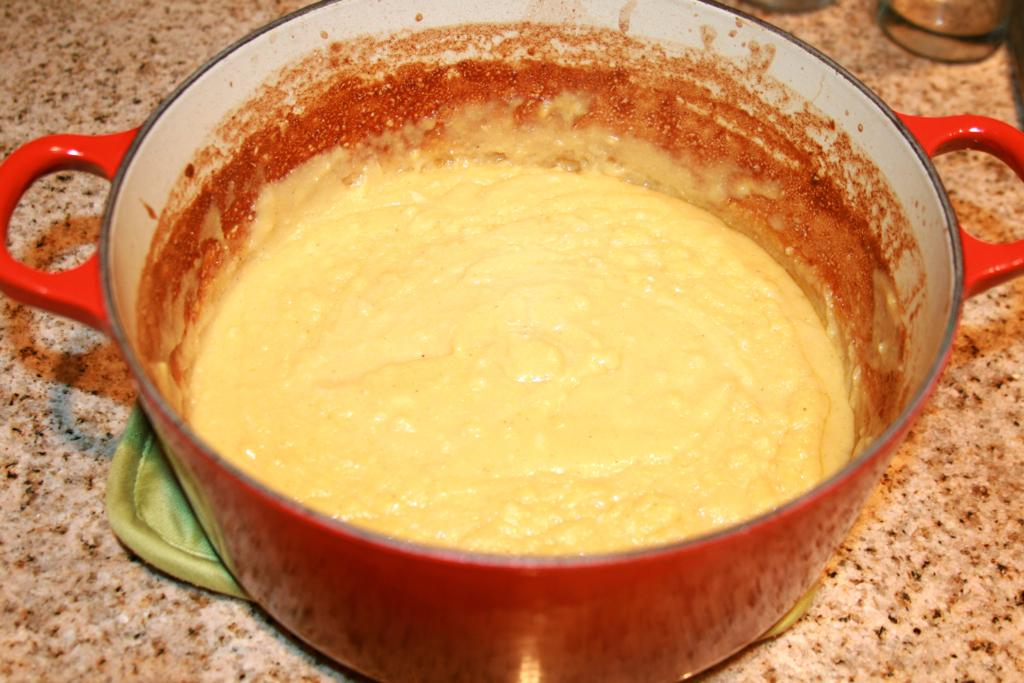What is in the bowl that is visible in the image? There is food in the bowl in the image. What can be said about the color of the food in the bowl? The food is yellow in color. Where is the bowl located in the image? The bowl is on a tray. What is the color of the surface that the tray is on? The tray is on a brown-colored surface. What type of shoe can be seen in the image? There is no shoe present in the image. Can you identify the actor who is serving the food in the image? There is no actor present in the image; it is a still image of food in a bowl. 